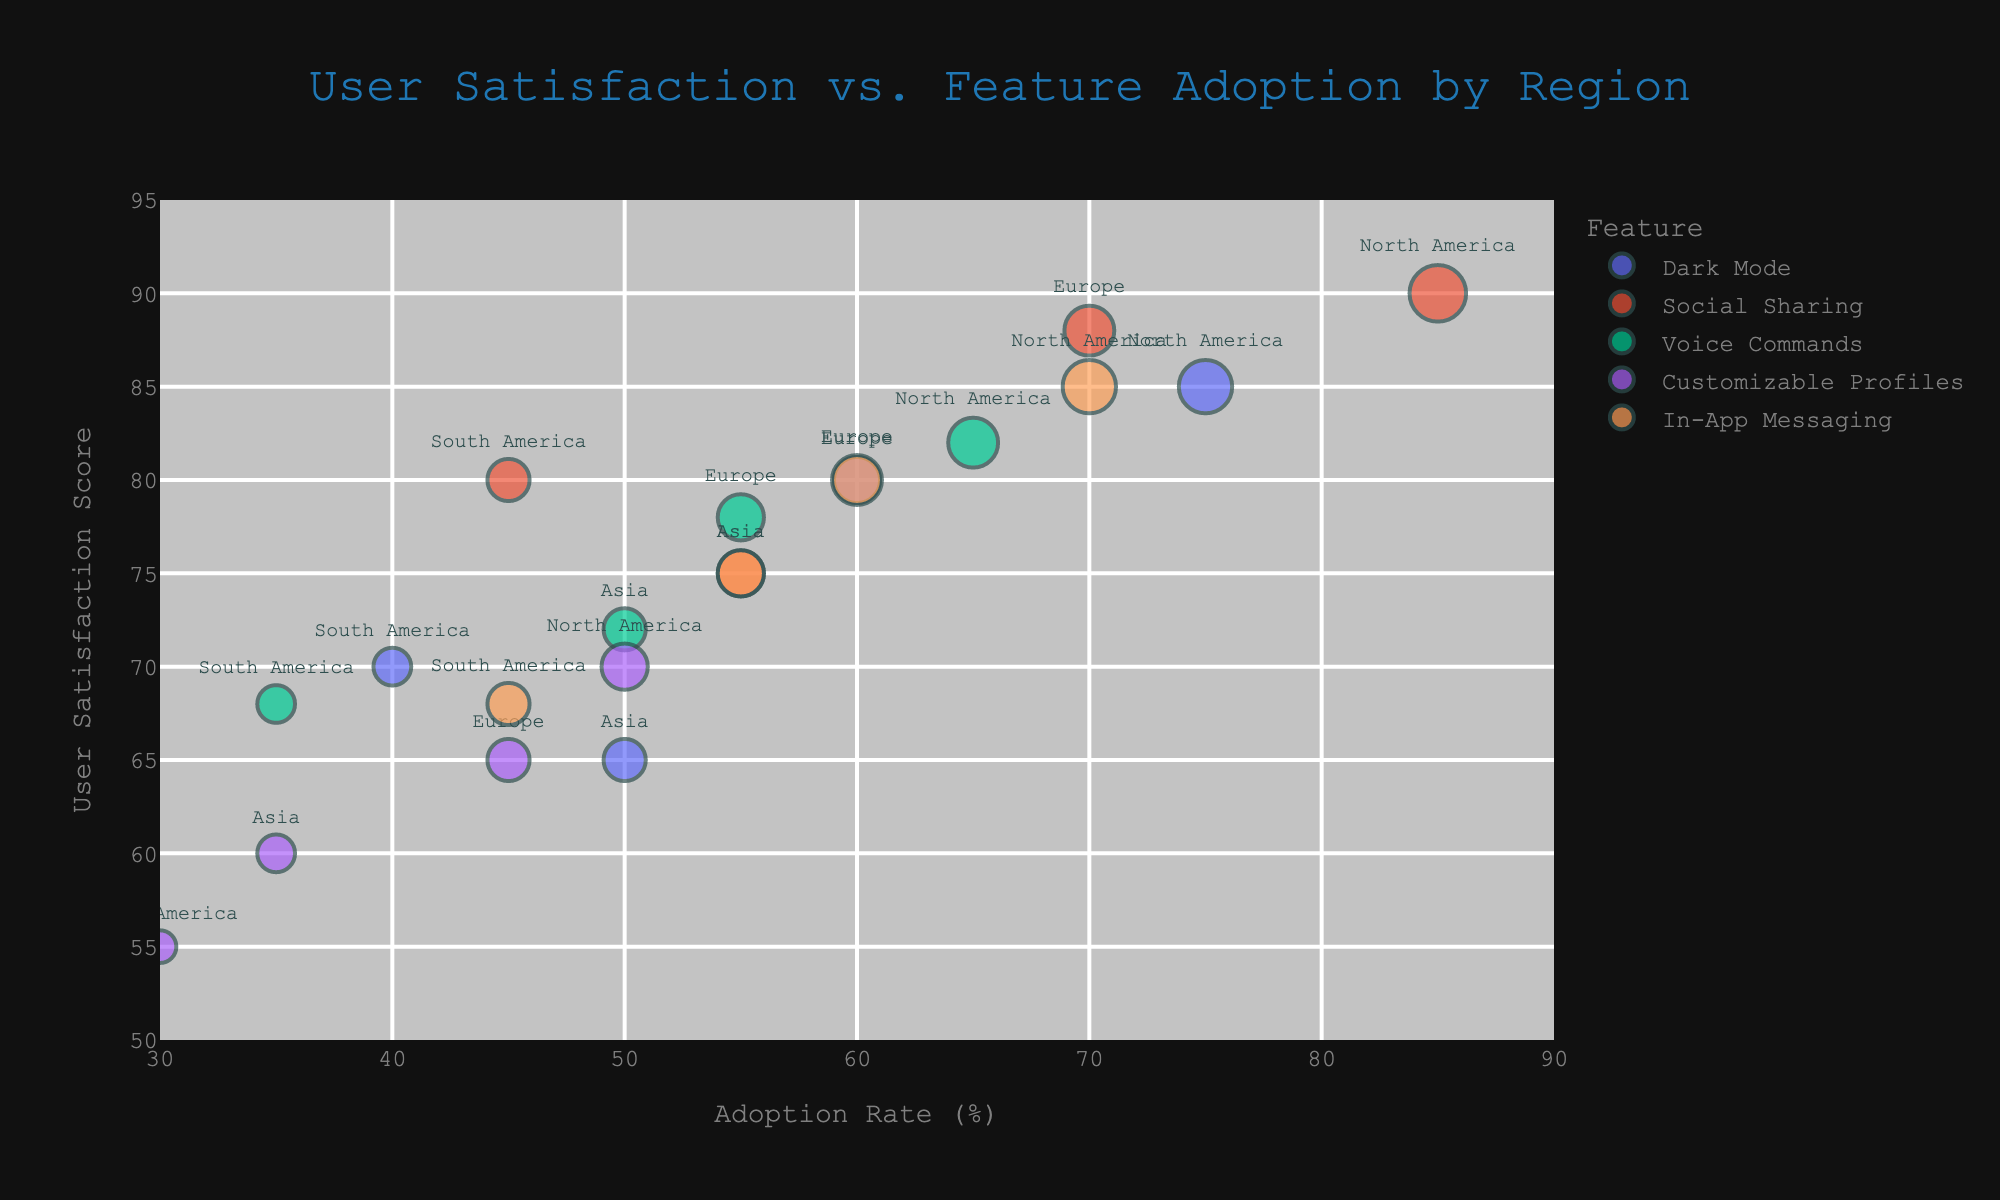what is the title of the figure? The title is displayed at the center top of the figure, which summarizes what the plot represents.
Answer: User Satisfaction vs. Feature Adoption by Region How many geographic regions are represented in the figure? The geographic regions are shown as text labels next to the bubbles. By counting these, we identify four regions: North America, Europe, Asia, and South America.
Answer: 4 Which feature has the highest adoption rate in North America? Look for the bubble with the highest "Adoption Rate (%)" on the x-axis corresponding to the "North America" hover label.
Answer: Social Sharing What is the user satisfaction score for Customizable Profiles in Asia? Identify the bubble labeled "Asia" and track it to the feature "Customizable Profiles" on the graph. The corresponding user's satisfaction score is on the y-axis.
Answer: 60 Which geographic region has the lowest user satisfaction score for Dark Mode? Compare the y-axis values under the label "Dark Mode" for different regions, and find the lowest score.
Answer: Asia Between Voice Commands and In-App Messaging, which feature has a higher adoption rate in Europe? Compare the x-axis values for the bubbles labeled "Europe" under the features "Voice Commands" and "In-App Messaging."
Answer: In-App Messaging What is the difference in user satisfaction scores for Social Sharing between North America and South America? Locate the y-axis values for the "Social Sharing" feature in "North America" and "South America" and subtract the smaller value from the larger one.
Answer: 10 Which feature has the largest bubble size in the figure, and what does it represent? Identify the largest bubble by visually inspecting the plot or checking the "Bubble Size" values, considering that larger sizes indicate higher scores.
Answer: Social Sharing (North America, size 9) How does the adoption rate of Customizable Profiles in South America compare to the voice commands in Asia? Compare the x-axis values for "Customizable Profiles" in "South America" and "Voice Commands" in "Asia."
Answer: Customizable Profiles in South America is lower What is the average user satisfaction score for In-App Messaging across all regions? Sum the user satisfaction scores for "In-App Messaging" in all regions and divide by the number of regions (4). (85 + 80 + 75 + 68) / 4 = 77
Answer: 77 